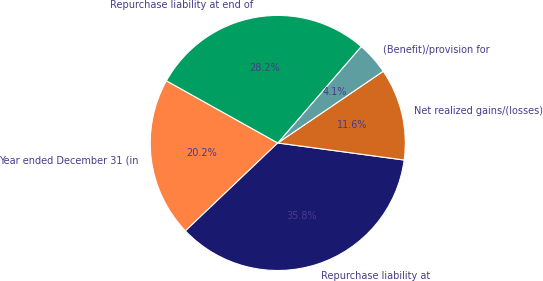<chart> <loc_0><loc_0><loc_500><loc_500><pie_chart><fcel>Year ended December 31 (in<fcel>Repurchase liability at<fcel>Net realized gains/(losses)<fcel>(Benefit)/provision for<fcel>Repurchase liability at end of<nl><fcel>20.22%<fcel>35.75%<fcel>11.64%<fcel>4.14%<fcel>28.25%<nl></chart> 